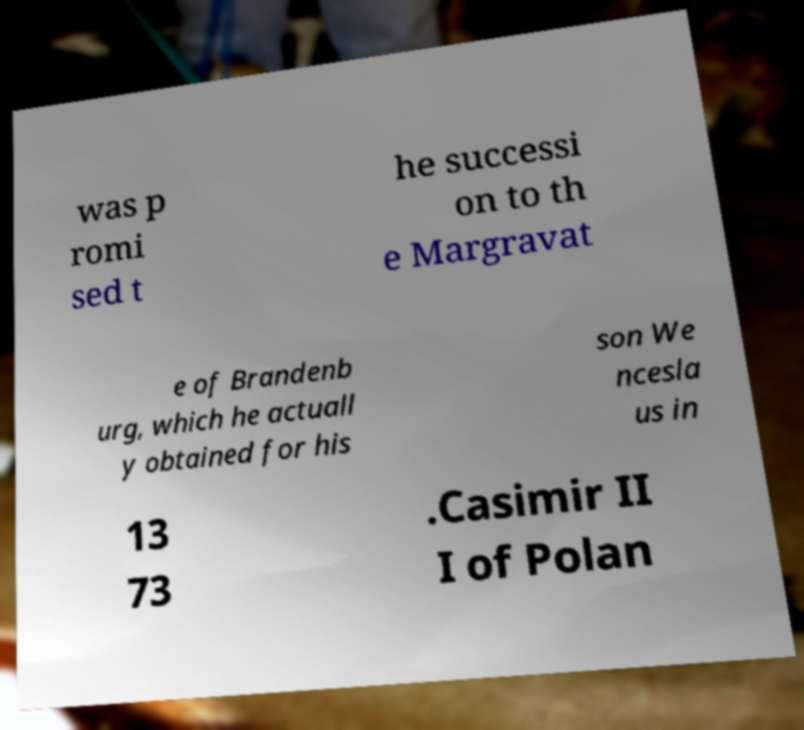Please identify and transcribe the text found in this image. was p romi sed t he successi on to th e Margravat e of Brandenb urg, which he actuall y obtained for his son We ncesla us in 13 73 .Casimir II I of Polan 